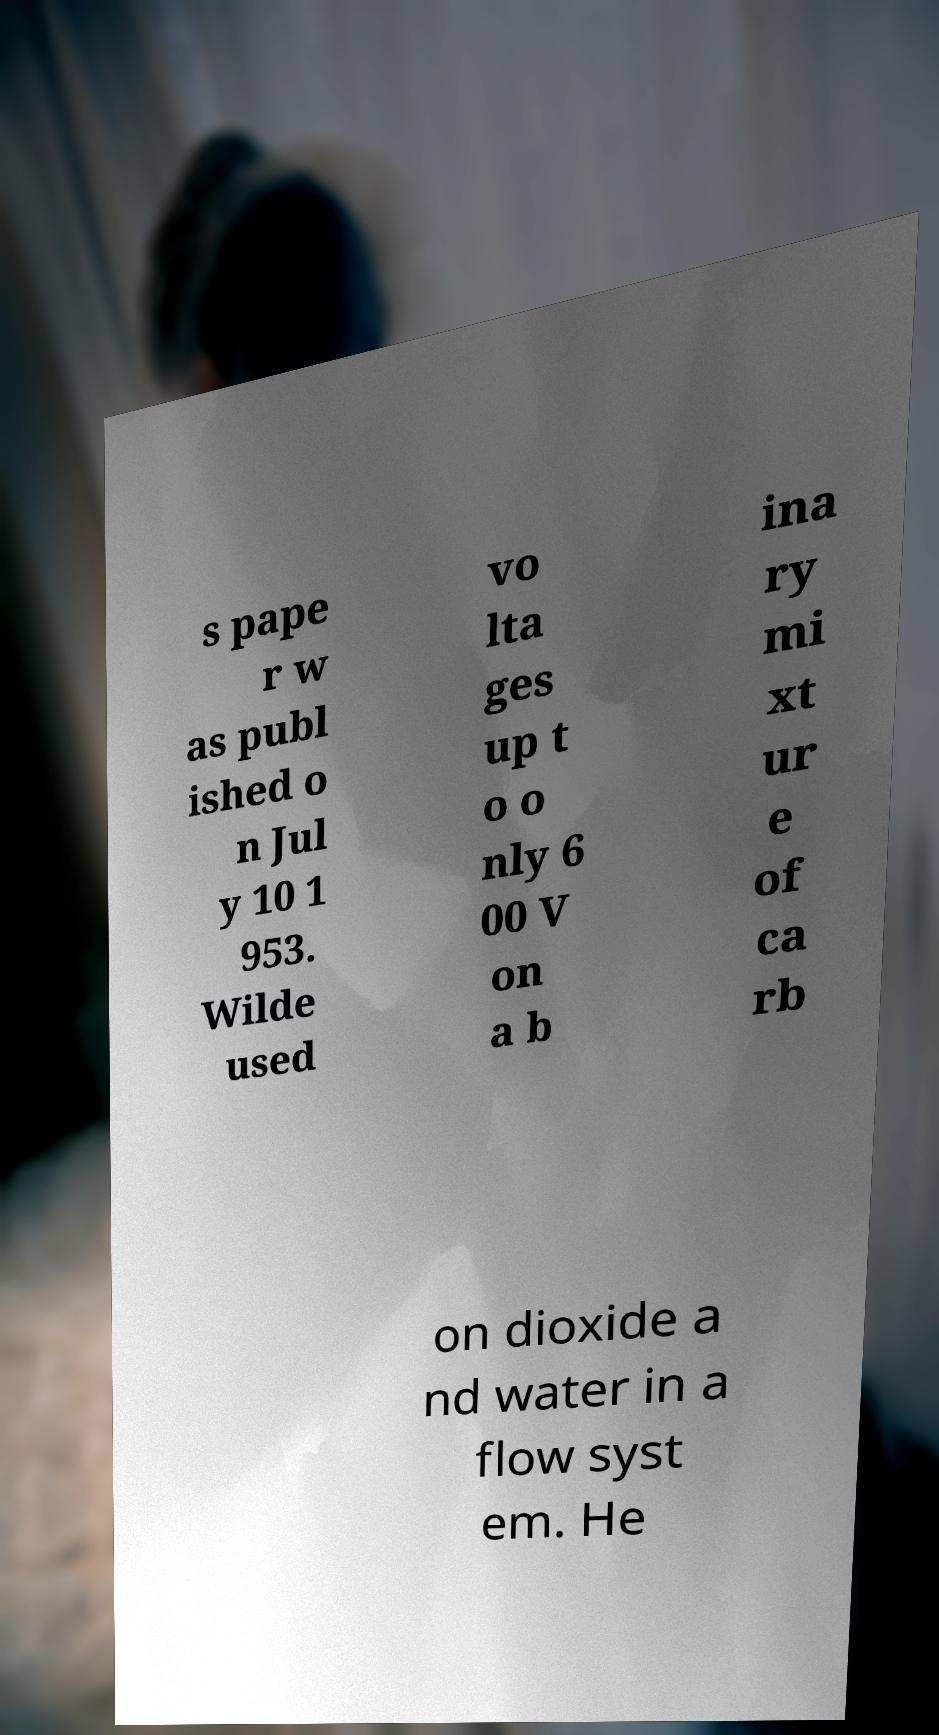Please read and relay the text visible in this image. What does it say? s pape r w as publ ished o n Jul y 10 1 953. Wilde used vo lta ges up t o o nly 6 00 V on a b ina ry mi xt ur e of ca rb on dioxide a nd water in a flow syst em. He 